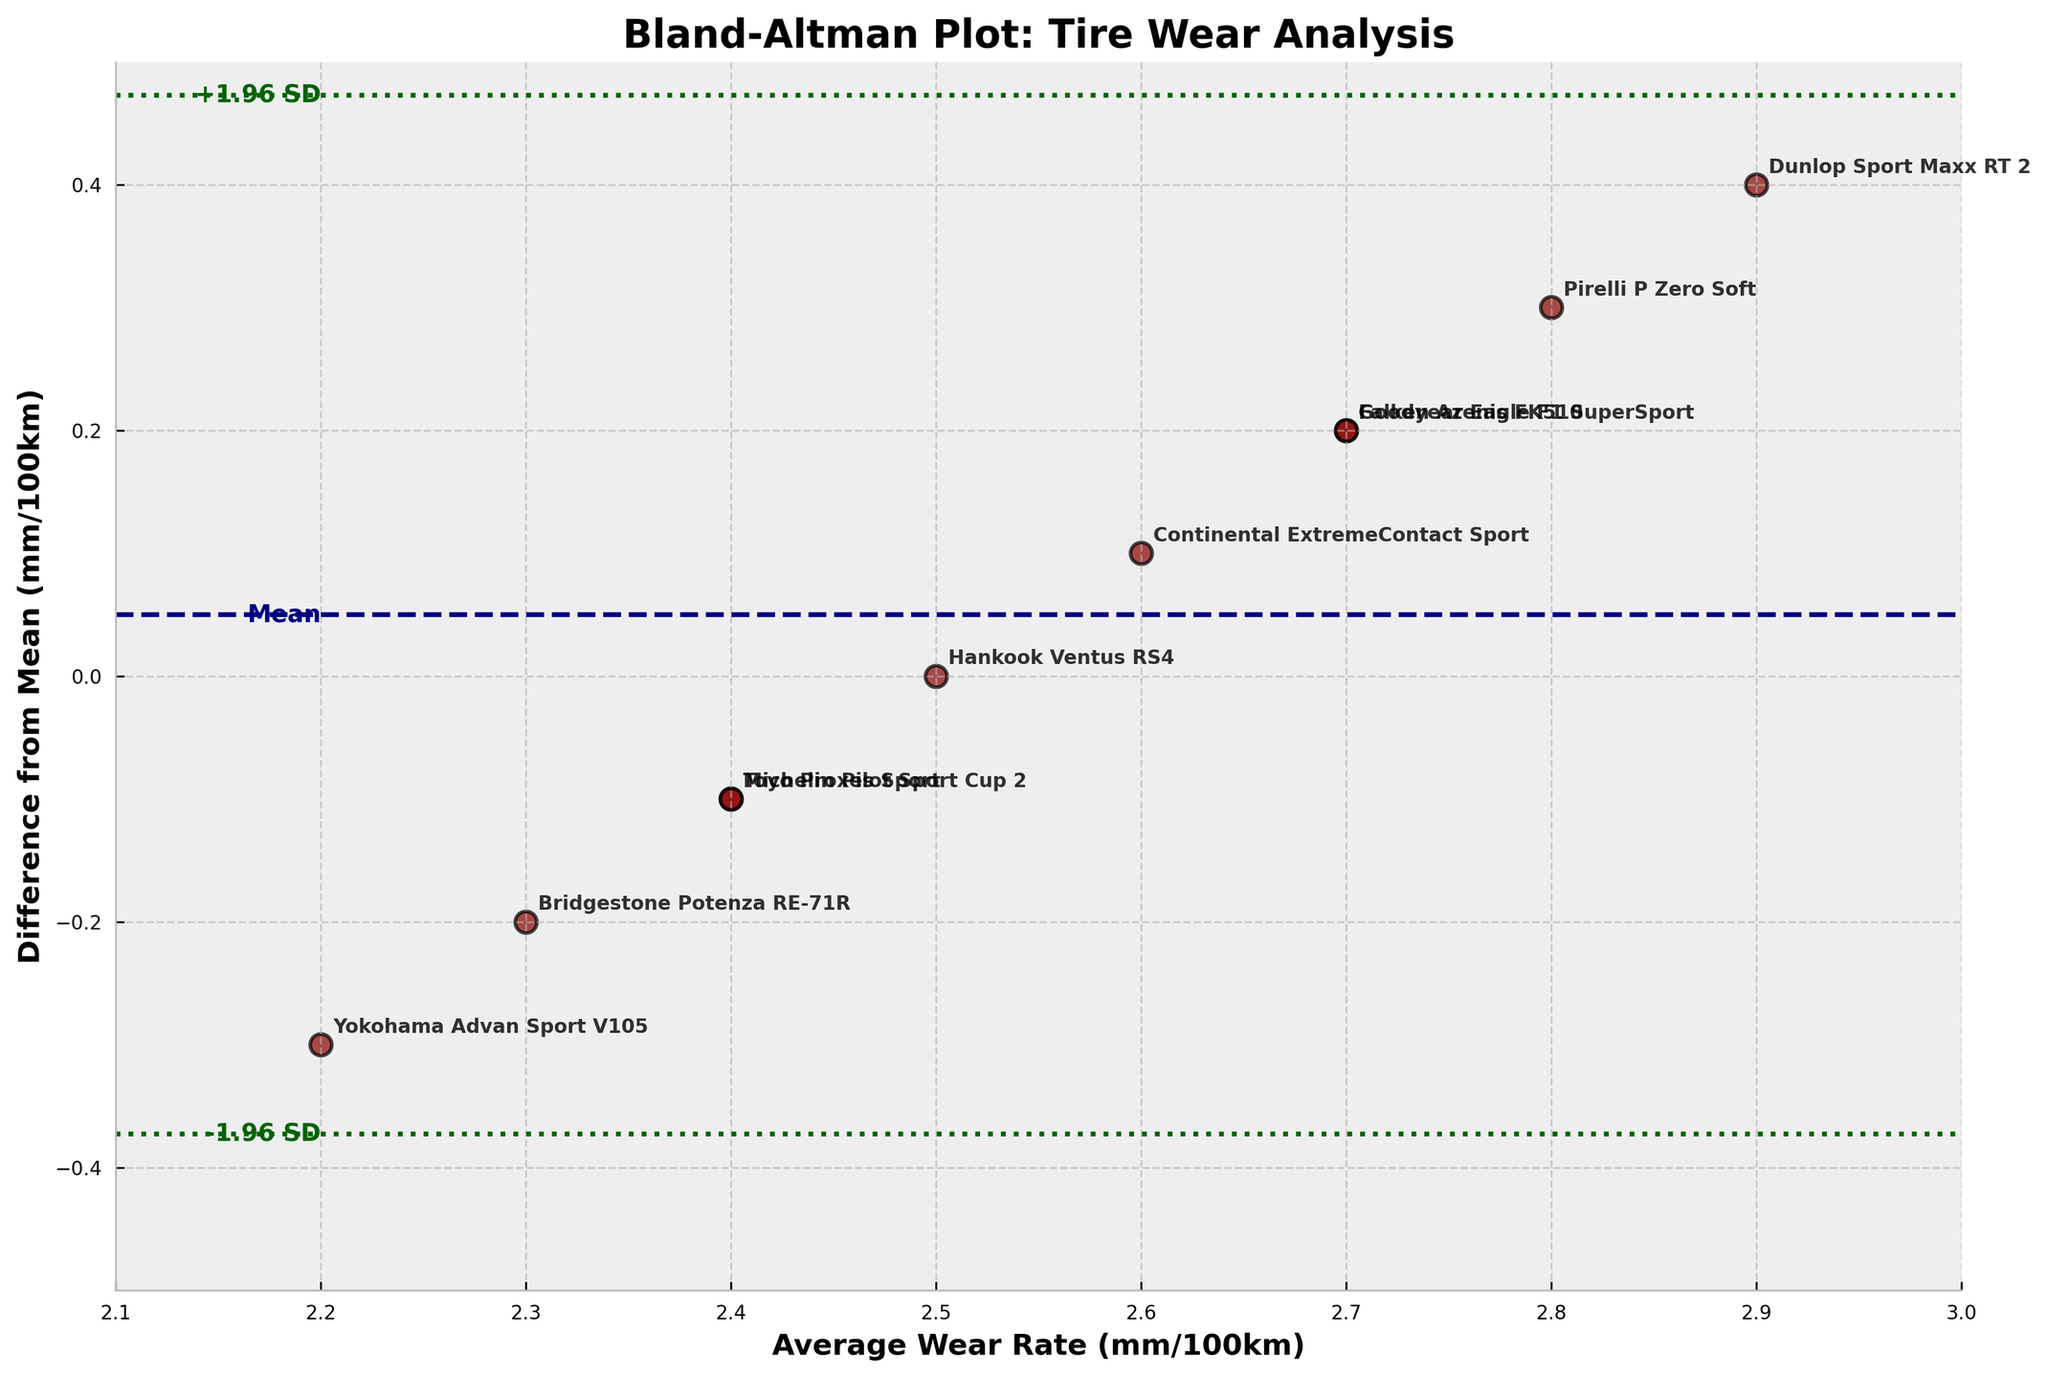What's the title of the plot? The title is positioned at the top of the plot and is highlighted in bold.
Answer: Bland-Altman Plot: Tire Wear Analysis What is the average difference from the mean for tire compounds? The average difference from the mean is illustrated by the navy dashed line, which is annotated as 'Mean'.
Answer: 0 mm/100km How many tire compounds fall within the +1.96 SD and -1.96 SD limits of agreement? Both the +1.96 SD and -1.96 SD limits are indicated by dark green dotted lines. You can count the number of data points (red dots) that fall within these lines.
Answer: 10 Which tire compound has the highest average wear rate? The average wear rate is shown on the x-axis. The data point with the highest x-axis value represents the tire compound with the highest rate. Cross-checking with the annotations will reveal the tire named.
Answer: Dunlop Sport Maxx RT 2 How is the wear rate for Michelin Pilot Sport Cup 2 different from the mean wear rate? Find the data point labeled 'Michelin Pilot Sport Cup 2' and check its y-axis value for the difference from the mean.
Answer: -0.1 mm/100km Which tire compound has the greatest deviation from the average wear rate and what is the value? Identify the data point farthest away from the horizontal mean difference line and check its y-axis value and label.
Answer: Dunlop Sport Maxx RT 2, 0.4 mm/100km What are the +1.96 SD and -1.96 SD limits of agreement in mm/100km? The limits of agreement are shown as two green dotted horizontal lines and are annotated on the plot.
Answer: +0.392 and -0.392 mm/100km Is there any tire compound with a negative difference from the mean exceeding -0.3 mm/100km? Look for any data point below the -0.3 mm/100km value on the y-axis. Check the corresponding compound label.
Answer: Yokohama Advan Sport V105 Calculate the spread between the highest and lowest average wear rates among the tire compounds. The highest average wear rate is 2.9 mm/100km (Dunlop Sport Maxx RT 2) and the lowest is 2.2 mm/100km (Yokohama Advan Sport V105). The spread is 2.9 - 2.2.
Answer: 0.7 mm/100km How many tire compounds have an average wear rate of 2.7 mm/100km? Check the x-axis for data points with an average wear rate of 2.7 mm/100km and count them.
Answer: 2 